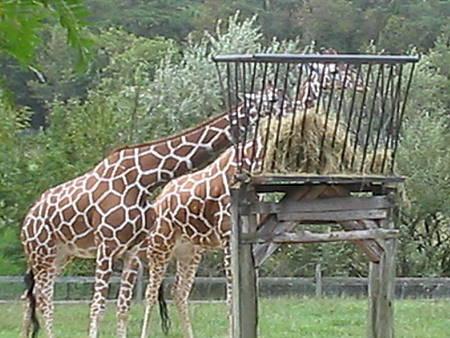Is it possible to see the giraffes faces?
Keep it brief. Yes. Are the giraffes eating?
Concise answer only. Yes. Why is the feed so high?
Answer briefly. Long necks. What are the giraffes doing?
Concise answer only. Eating. 